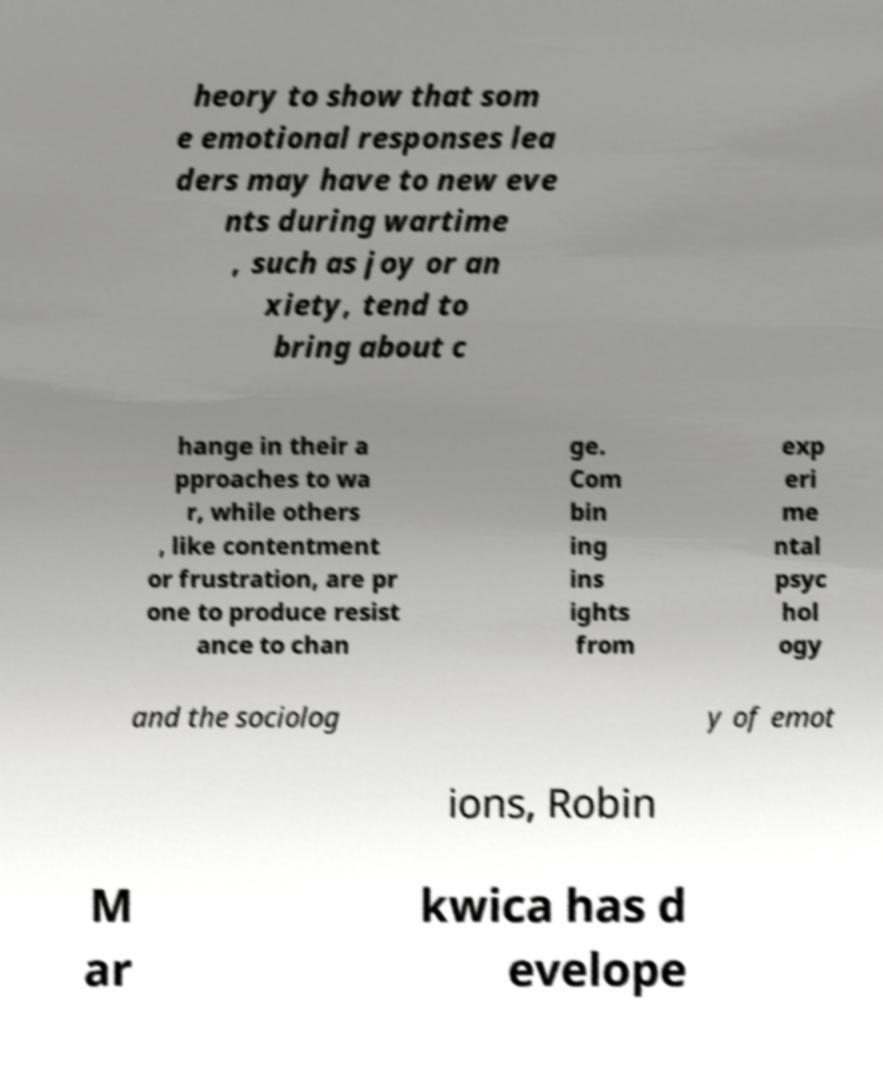Can you accurately transcribe the text from the provided image for me? heory to show that som e emotional responses lea ders may have to new eve nts during wartime , such as joy or an xiety, tend to bring about c hange in their a pproaches to wa r, while others , like contentment or frustration, are pr one to produce resist ance to chan ge. Com bin ing ins ights from exp eri me ntal psyc hol ogy and the sociolog y of emot ions, Robin M ar kwica has d evelope 